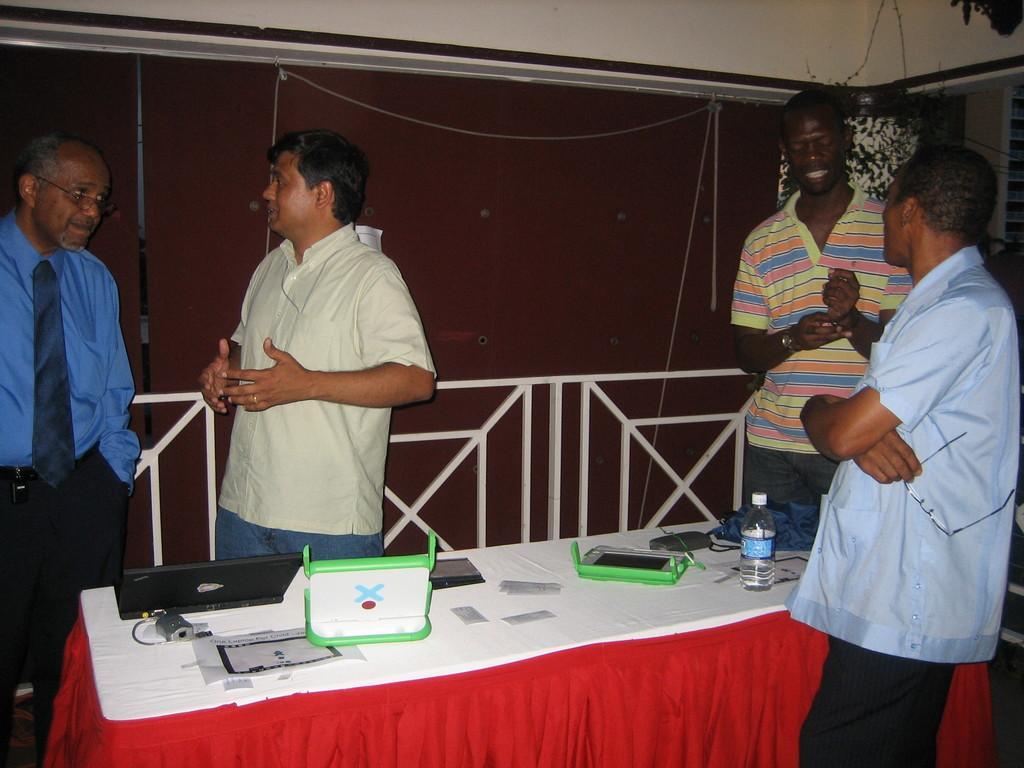In one or two sentences, can you explain what this image depicts? In this image I can see four people standing. In front of them there is a laptop,bottle and some of the objects on the table. At the back side there is a wall. 